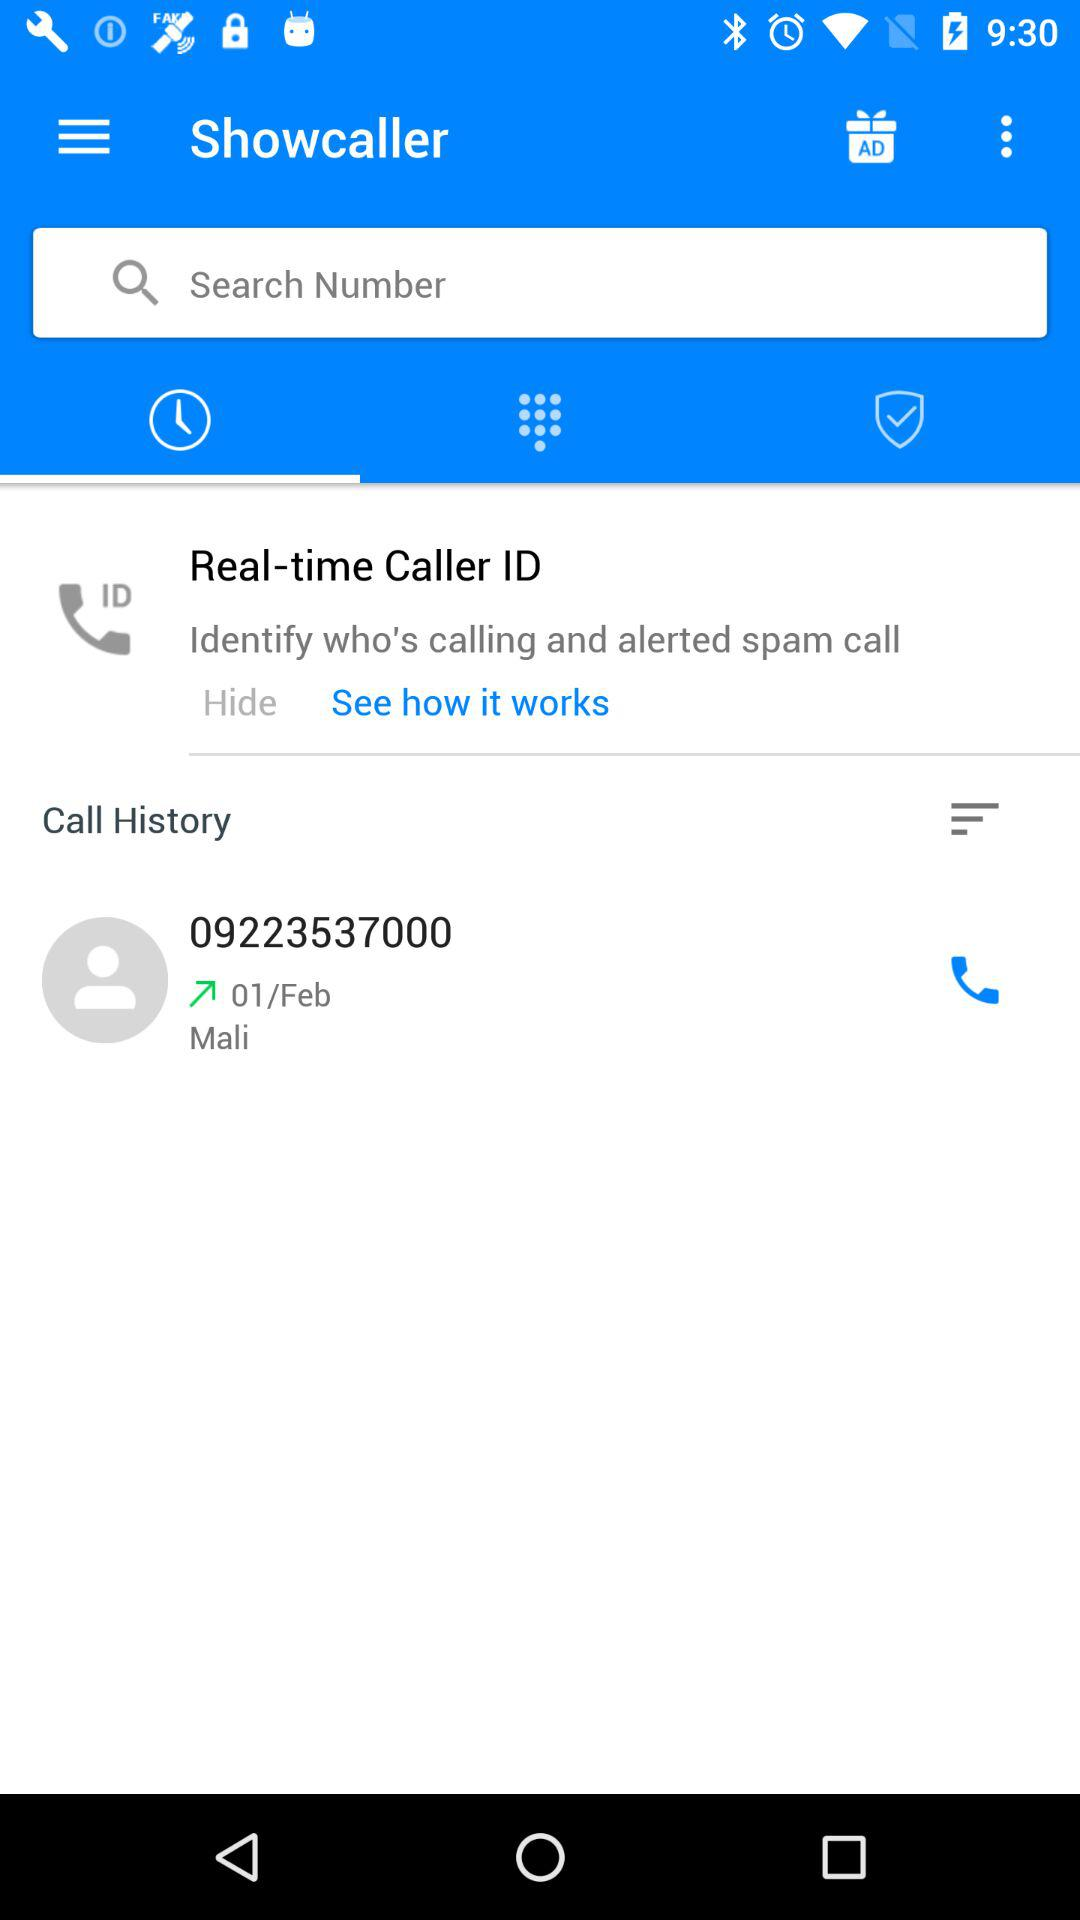When was the number dialed? The number was dialed on February 1. 